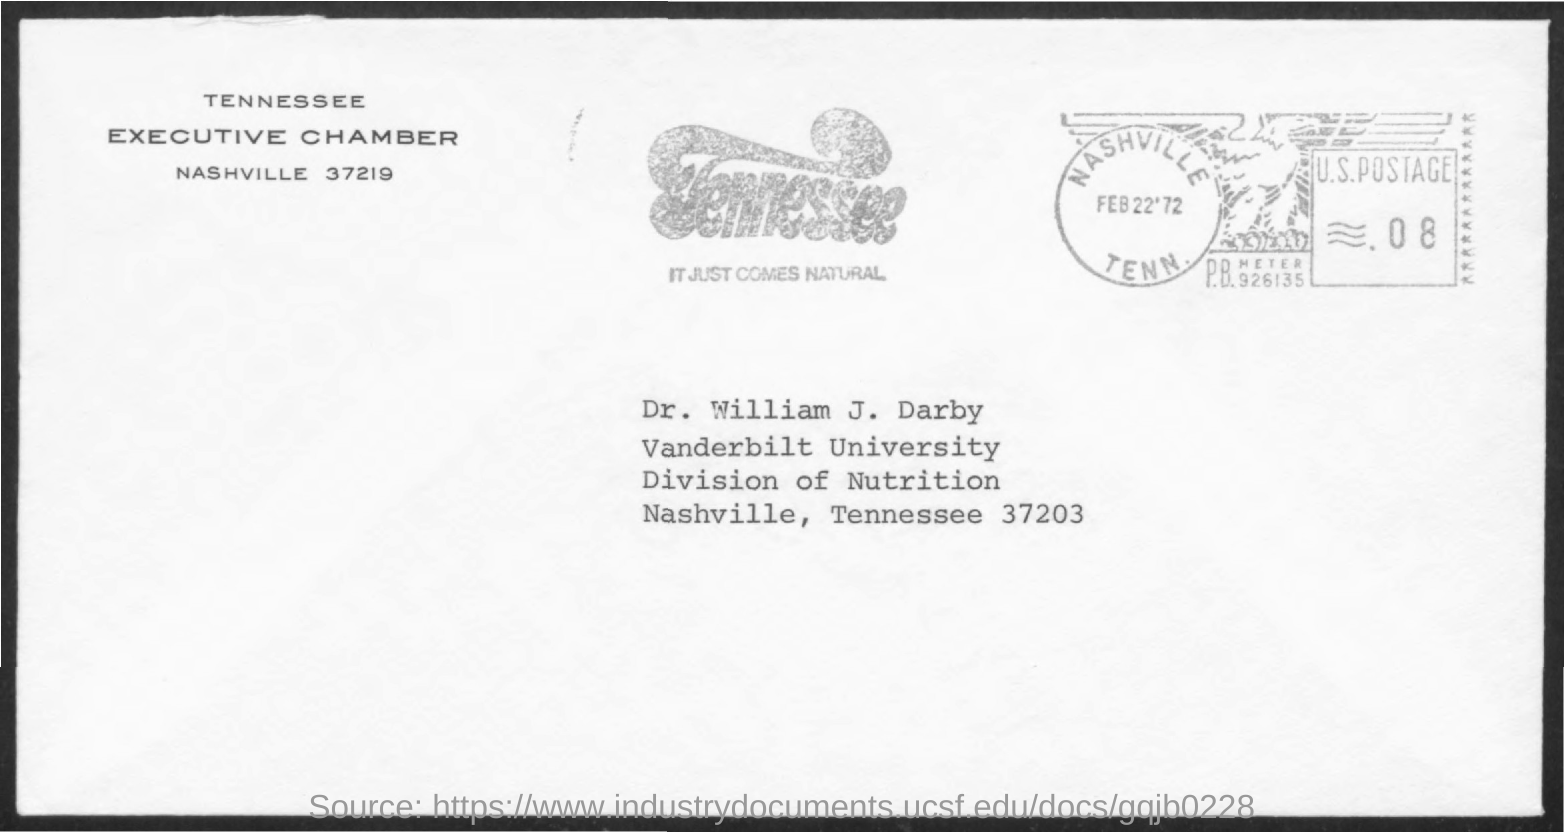To Whom is this letter addressed to?
Give a very brief answer. DR. WILLIAM J. DARBY. Who is it from?
Offer a terse response. TENNESSEE EXECUTIVE CHAMBER. 